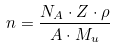Convert formula to latex. <formula><loc_0><loc_0><loc_500><loc_500>n = \frac { N _ { A } \cdot Z \cdot \rho } { A \cdot M _ { u } }</formula> 